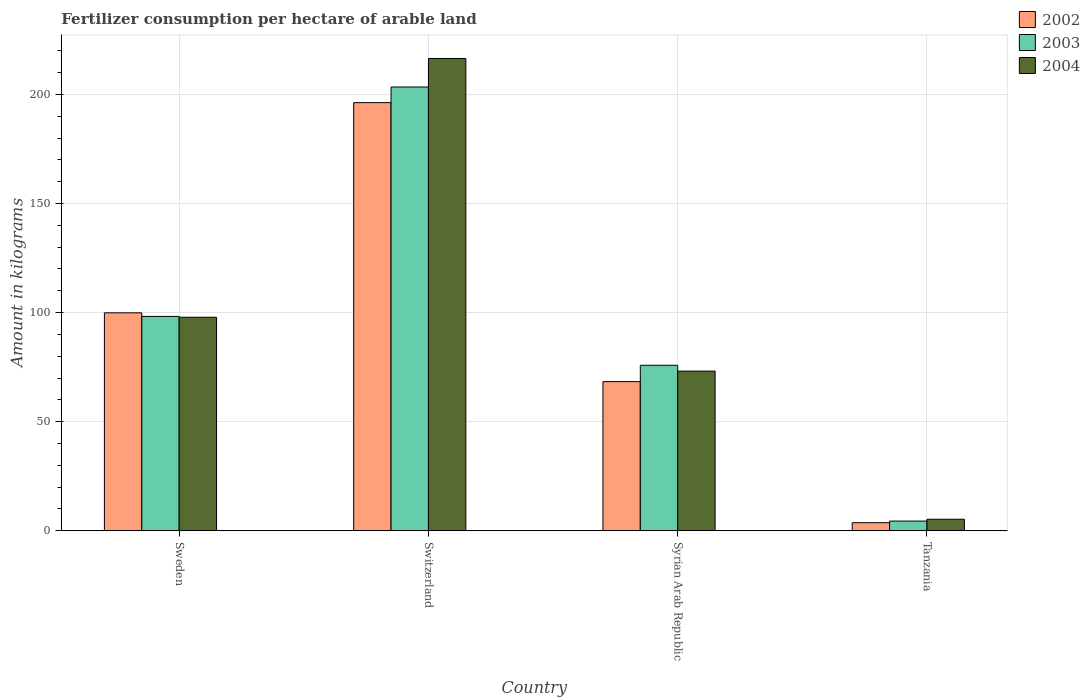How many different coloured bars are there?
Ensure brevity in your answer.  3. How many groups of bars are there?
Offer a terse response. 4. Are the number of bars per tick equal to the number of legend labels?
Your response must be concise. Yes. How many bars are there on the 4th tick from the right?
Provide a short and direct response. 3. What is the label of the 4th group of bars from the left?
Your answer should be very brief. Tanzania. What is the amount of fertilizer consumption in 2004 in Sweden?
Provide a succinct answer. 97.85. Across all countries, what is the maximum amount of fertilizer consumption in 2003?
Offer a terse response. 203.37. Across all countries, what is the minimum amount of fertilizer consumption in 2004?
Offer a terse response. 5.29. In which country was the amount of fertilizer consumption in 2004 maximum?
Ensure brevity in your answer.  Switzerland. In which country was the amount of fertilizer consumption in 2003 minimum?
Your response must be concise. Tanzania. What is the total amount of fertilizer consumption in 2004 in the graph?
Ensure brevity in your answer.  392.76. What is the difference between the amount of fertilizer consumption in 2004 in Switzerland and that in Syrian Arab Republic?
Ensure brevity in your answer.  143.26. What is the difference between the amount of fertilizer consumption in 2003 in Sweden and the amount of fertilizer consumption in 2002 in Syrian Arab Republic?
Keep it short and to the point. 29.88. What is the average amount of fertilizer consumption in 2003 per country?
Provide a succinct answer. 95.48. What is the difference between the amount of fertilizer consumption of/in 2004 and amount of fertilizer consumption of/in 2003 in Syrian Arab Republic?
Ensure brevity in your answer.  -2.67. In how many countries, is the amount of fertilizer consumption in 2002 greater than 190 kg?
Your answer should be very brief. 1. What is the ratio of the amount of fertilizer consumption in 2003 in Sweden to that in Switzerland?
Your answer should be very brief. 0.48. What is the difference between the highest and the second highest amount of fertilizer consumption in 2002?
Keep it short and to the point. -96.32. What is the difference between the highest and the lowest amount of fertilizer consumption in 2003?
Keep it short and to the point. 198.91. Is the sum of the amount of fertilizer consumption in 2003 in Sweden and Syrian Arab Republic greater than the maximum amount of fertilizer consumption in 2004 across all countries?
Offer a terse response. No. What does the 2nd bar from the left in Tanzania represents?
Your answer should be very brief. 2003. What does the 2nd bar from the right in Switzerland represents?
Your answer should be compact. 2003. How many countries are there in the graph?
Your answer should be very brief. 4. What is the difference between two consecutive major ticks on the Y-axis?
Your response must be concise. 50. Are the values on the major ticks of Y-axis written in scientific E-notation?
Provide a short and direct response. No. Does the graph contain any zero values?
Provide a short and direct response. No. How are the legend labels stacked?
Ensure brevity in your answer.  Vertical. What is the title of the graph?
Give a very brief answer. Fertilizer consumption per hectare of arable land. What is the label or title of the X-axis?
Offer a terse response. Country. What is the label or title of the Y-axis?
Provide a short and direct response. Amount in kilograms. What is the Amount in kilograms of 2002 in Sweden?
Keep it short and to the point. 99.89. What is the Amount in kilograms of 2003 in Sweden?
Give a very brief answer. 98.24. What is the Amount in kilograms of 2004 in Sweden?
Your answer should be very brief. 97.85. What is the Amount in kilograms in 2002 in Switzerland?
Provide a succinct answer. 196.21. What is the Amount in kilograms of 2003 in Switzerland?
Your response must be concise. 203.37. What is the Amount in kilograms in 2004 in Switzerland?
Provide a succinct answer. 216.44. What is the Amount in kilograms in 2002 in Syrian Arab Republic?
Give a very brief answer. 68.35. What is the Amount in kilograms of 2003 in Syrian Arab Republic?
Make the answer very short. 75.85. What is the Amount in kilograms in 2004 in Syrian Arab Republic?
Make the answer very short. 73.18. What is the Amount in kilograms of 2002 in Tanzania?
Provide a short and direct response. 3.7. What is the Amount in kilograms in 2003 in Tanzania?
Your answer should be very brief. 4.46. What is the Amount in kilograms of 2004 in Tanzania?
Offer a terse response. 5.29. Across all countries, what is the maximum Amount in kilograms of 2002?
Your response must be concise. 196.21. Across all countries, what is the maximum Amount in kilograms in 2003?
Your answer should be compact. 203.37. Across all countries, what is the maximum Amount in kilograms of 2004?
Keep it short and to the point. 216.44. Across all countries, what is the minimum Amount in kilograms in 2002?
Ensure brevity in your answer.  3.7. Across all countries, what is the minimum Amount in kilograms of 2003?
Your answer should be compact. 4.46. Across all countries, what is the minimum Amount in kilograms of 2004?
Keep it short and to the point. 5.29. What is the total Amount in kilograms in 2002 in the graph?
Your answer should be compact. 368.15. What is the total Amount in kilograms in 2003 in the graph?
Give a very brief answer. 381.91. What is the total Amount in kilograms in 2004 in the graph?
Provide a short and direct response. 392.76. What is the difference between the Amount in kilograms of 2002 in Sweden and that in Switzerland?
Your answer should be compact. -96.32. What is the difference between the Amount in kilograms in 2003 in Sweden and that in Switzerland?
Offer a very short reply. -105.13. What is the difference between the Amount in kilograms of 2004 in Sweden and that in Switzerland?
Offer a terse response. -118.58. What is the difference between the Amount in kilograms of 2002 in Sweden and that in Syrian Arab Republic?
Offer a terse response. 31.54. What is the difference between the Amount in kilograms of 2003 in Sweden and that in Syrian Arab Republic?
Your response must be concise. 22.39. What is the difference between the Amount in kilograms of 2004 in Sweden and that in Syrian Arab Republic?
Offer a terse response. 24.67. What is the difference between the Amount in kilograms of 2002 in Sweden and that in Tanzania?
Offer a very short reply. 96.19. What is the difference between the Amount in kilograms of 2003 in Sweden and that in Tanzania?
Keep it short and to the point. 93.78. What is the difference between the Amount in kilograms of 2004 in Sweden and that in Tanzania?
Keep it short and to the point. 92.56. What is the difference between the Amount in kilograms of 2002 in Switzerland and that in Syrian Arab Republic?
Provide a short and direct response. 127.85. What is the difference between the Amount in kilograms of 2003 in Switzerland and that in Syrian Arab Republic?
Your answer should be very brief. 127.52. What is the difference between the Amount in kilograms in 2004 in Switzerland and that in Syrian Arab Republic?
Offer a terse response. 143.26. What is the difference between the Amount in kilograms in 2002 in Switzerland and that in Tanzania?
Give a very brief answer. 192.51. What is the difference between the Amount in kilograms in 2003 in Switzerland and that in Tanzania?
Offer a terse response. 198.91. What is the difference between the Amount in kilograms of 2004 in Switzerland and that in Tanzania?
Your answer should be compact. 211.15. What is the difference between the Amount in kilograms of 2002 in Syrian Arab Republic and that in Tanzania?
Your answer should be compact. 64.65. What is the difference between the Amount in kilograms of 2003 in Syrian Arab Republic and that in Tanzania?
Keep it short and to the point. 71.39. What is the difference between the Amount in kilograms of 2004 in Syrian Arab Republic and that in Tanzania?
Your response must be concise. 67.89. What is the difference between the Amount in kilograms in 2002 in Sweden and the Amount in kilograms in 2003 in Switzerland?
Make the answer very short. -103.48. What is the difference between the Amount in kilograms in 2002 in Sweden and the Amount in kilograms in 2004 in Switzerland?
Offer a very short reply. -116.55. What is the difference between the Amount in kilograms in 2003 in Sweden and the Amount in kilograms in 2004 in Switzerland?
Your answer should be very brief. -118.2. What is the difference between the Amount in kilograms in 2002 in Sweden and the Amount in kilograms in 2003 in Syrian Arab Republic?
Your response must be concise. 24.04. What is the difference between the Amount in kilograms of 2002 in Sweden and the Amount in kilograms of 2004 in Syrian Arab Republic?
Offer a terse response. 26.71. What is the difference between the Amount in kilograms in 2003 in Sweden and the Amount in kilograms in 2004 in Syrian Arab Republic?
Make the answer very short. 25.06. What is the difference between the Amount in kilograms of 2002 in Sweden and the Amount in kilograms of 2003 in Tanzania?
Provide a succinct answer. 95.43. What is the difference between the Amount in kilograms of 2002 in Sweden and the Amount in kilograms of 2004 in Tanzania?
Make the answer very short. 94.6. What is the difference between the Amount in kilograms of 2003 in Sweden and the Amount in kilograms of 2004 in Tanzania?
Offer a terse response. 92.95. What is the difference between the Amount in kilograms of 2002 in Switzerland and the Amount in kilograms of 2003 in Syrian Arab Republic?
Ensure brevity in your answer.  120.36. What is the difference between the Amount in kilograms of 2002 in Switzerland and the Amount in kilograms of 2004 in Syrian Arab Republic?
Give a very brief answer. 123.03. What is the difference between the Amount in kilograms in 2003 in Switzerland and the Amount in kilograms in 2004 in Syrian Arab Republic?
Offer a very short reply. 130.19. What is the difference between the Amount in kilograms in 2002 in Switzerland and the Amount in kilograms in 2003 in Tanzania?
Provide a succinct answer. 191.75. What is the difference between the Amount in kilograms of 2002 in Switzerland and the Amount in kilograms of 2004 in Tanzania?
Keep it short and to the point. 190.92. What is the difference between the Amount in kilograms in 2003 in Switzerland and the Amount in kilograms in 2004 in Tanzania?
Provide a succinct answer. 198.08. What is the difference between the Amount in kilograms of 2002 in Syrian Arab Republic and the Amount in kilograms of 2003 in Tanzania?
Your answer should be very brief. 63.9. What is the difference between the Amount in kilograms in 2002 in Syrian Arab Republic and the Amount in kilograms in 2004 in Tanzania?
Provide a short and direct response. 63.06. What is the difference between the Amount in kilograms of 2003 in Syrian Arab Republic and the Amount in kilograms of 2004 in Tanzania?
Ensure brevity in your answer.  70.56. What is the average Amount in kilograms of 2002 per country?
Offer a terse response. 92.04. What is the average Amount in kilograms in 2003 per country?
Your response must be concise. 95.48. What is the average Amount in kilograms of 2004 per country?
Make the answer very short. 98.19. What is the difference between the Amount in kilograms in 2002 and Amount in kilograms in 2003 in Sweden?
Make the answer very short. 1.65. What is the difference between the Amount in kilograms of 2002 and Amount in kilograms of 2004 in Sweden?
Your answer should be compact. 2.03. What is the difference between the Amount in kilograms of 2003 and Amount in kilograms of 2004 in Sweden?
Provide a succinct answer. 0.38. What is the difference between the Amount in kilograms of 2002 and Amount in kilograms of 2003 in Switzerland?
Provide a short and direct response. -7.16. What is the difference between the Amount in kilograms of 2002 and Amount in kilograms of 2004 in Switzerland?
Give a very brief answer. -20.23. What is the difference between the Amount in kilograms of 2003 and Amount in kilograms of 2004 in Switzerland?
Provide a succinct answer. -13.07. What is the difference between the Amount in kilograms of 2002 and Amount in kilograms of 2003 in Syrian Arab Republic?
Make the answer very short. -7.5. What is the difference between the Amount in kilograms in 2002 and Amount in kilograms in 2004 in Syrian Arab Republic?
Offer a very short reply. -4.83. What is the difference between the Amount in kilograms in 2003 and Amount in kilograms in 2004 in Syrian Arab Republic?
Your response must be concise. 2.67. What is the difference between the Amount in kilograms of 2002 and Amount in kilograms of 2003 in Tanzania?
Provide a succinct answer. -0.76. What is the difference between the Amount in kilograms of 2002 and Amount in kilograms of 2004 in Tanzania?
Your answer should be very brief. -1.59. What is the difference between the Amount in kilograms in 2003 and Amount in kilograms in 2004 in Tanzania?
Offer a terse response. -0.83. What is the ratio of the Amount in kilograms in 2002 in Sweden to that in Switzerland?
Make the answer very short. 0.51. What is the ratio of the Amount in kilograms in 2003 in Sweden to that in Switzerland?
Your answer should be very brief. 0.48. What is the ratio of the Amount in kilograms of 2004 in Sweden to that in Switzerland?
Offer a terse response. 0.45. What is the ratio of the Amount in kilograms of 2002 in Sweden to that in Syrian Arab Republic?
Keep it short and to the point. 1.46. What is the ratio of the Amount in kilograms in 2003 in Sweden to that in Syrian Arab Republic?
Keep it short and to the point. 1.3. What is the ratio of the Amount in kilograms in 2004 in Sweden to that in Syrian Arab Republic?
Offer a terse response. 1.34. What is the ratio of the Amount in kilograms in 2002 in Sweden to that in Tanzania?
Make the answer very short. 27. What is the ratio of the Amount in kilograms of 2003 in Sweden to that in Tanzania?
Keep it short and to the point. 22.05. What is the ratio of the Amount in kilograms in 2004 in Sweden to that in Tanzania?
Offer a very short reply. 18.5. What is the ratio of the Amount in kilograms of 2002 in Switzerland to that in Syrian Arab Republic?
Make the answer very short. 2.87. What is the ratio of the Amount in kilograms in 2003 in Switzerland to that in Syrian Arab Republic?
Offer a terse response. 2.68. What is the ratio of the Amount in kilograms in 2004 in Switzerland to that in Syrian Arab Republic?
Ensure brevity in your answer.  2.96. What is the ratio of the Amount in kilograms of 2002 in Switzerland to that in Tanzania?
Keep it short and to the point. 53.03. What is the ratio of the Amount in kilograms of 2003 in Switzerland to that in Tanzania?
Make the answer very short. 45.64. What is the ratio of the Amount in kilograms in 2004 in Switzerland to that in Tanzania?
Make the answer very short. 40.92. What is the ratio of the Amount in kilograms in 2002 in Syrian Arab Republic to that in Tanzania?
Offer a terse response. 18.47. What is the ratio of the Amount in kilograms in 2003 in Syrian Arab Republic to that in Tanzania?
Ensure brevity in your answer.  17.02. What is the ratio of the Amount in kilograms in 2004 in Syrian Arab Republic to that in Tanzania?
Provide a short and direct response. 13.84. What is the difference between the highest and the second highest Amount in kilograms in 2002?
Your answer should be very brief. 96.32. What is the difference between the highest and the second highest Amount in kilograms in 2003?
Give a very brief answer. 105.13. What is the difference between the highest and the second highest Amount in kilograms in 2004?
Offer a very short reply. 118.58. What is the difference between the highest and the lowest Amount in kilograms of 2002?
Keep it short and to the point. 192.51. What is the difference between the highest and the lowest Amount in kilograms in 2003?
Make the answer very short. 198.91. What is the difference between the highest and the lowest Amount in kilograms in 2004?
Keep it short and to the point. 211.15. 